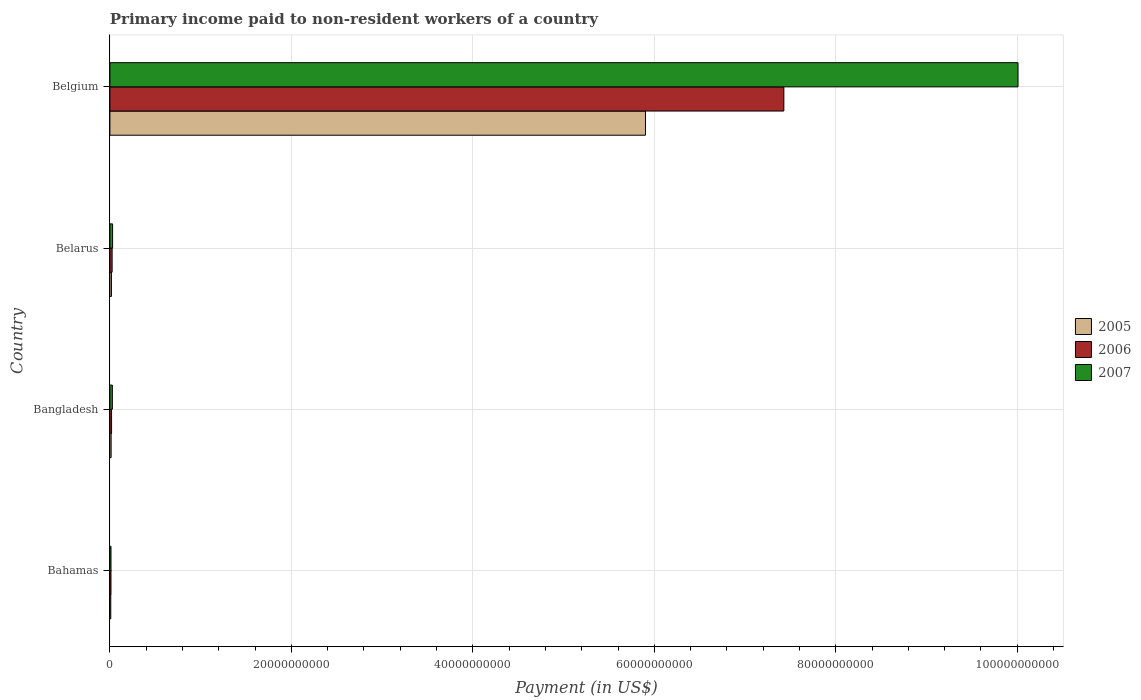How many different coloured bars are there?
Ensure brevity in your answer.  3. How many bars are there on the 2nd tick from the top?
Offer a terse response. 3. What is the amount paid to workers in 2005 in Belarus?
Your response must be concise. 1.68e+08. Across all countries, what is the maximum amount paid to workers in 2005?
Provide a short and direct response. 5.90e+1. Across all countries, what is the minimum amount paid to workers in 2006?
Your response must be concise. 1.19e+08. In which country was the amount paid to workers in 2005 maximum?
Your answer should be compact. Belgium. In which country was the amount paid to workers in 2005 minimum?
Provide a short and direct response. Bahamas. What is the total amount paid to workers in 2006 in the graph?
Keep it short and to the point. 7.48e+1. What is the difference between the amount paid to workers in 2006 in Bangladesh and that in Belarus?
Your answer should be very brief. -6.22e+07. What is the difference between the amount paid to workers in 2005 in Bahamas and the amount paid to workers in 2007 in Belarus?
Give a very brief answer. -2.00e+08. What is the average amount paid to workers in 2006 per country?
Your answer should be compact. 1.87e+1. What is the difference between the amount paid to workers in 2007 and amount paid to workers in 2005 in Bangladesh?
Keep it short and to the point. 1.37e+08. What is the ratio of the amount paid to workers in 2007 in Bahamas to that in Belarus?
Your answer should be compact. 0.41. Is the difference between the amount paid to workers in 2007 in Bangladesh and Belgium greater than the difference between the amount paid to workers in 2005 in Bangladesh and Belgium?
Give a very brief answer. No. What is the difference between the highest and the second highest amount paid to workers in 2007?
Your response must be concise. 9.98e+1. What is the difference between the highest and the lowest amount paid to workers in 2005?
Keep it short and to the point. 5.89e+1. How are the legend labels stacked?
Your response must be concise. Vertical. What is the title of the graph?
Offer a terse response. Primary income paid to non-resident workers of a country. Does "1982" appear as one of the legend labels in the graph?
Offer a very short reply. No. What is the label or title of the X-axis?
Keep it short and to the point. Payment (in US$). What is the label or title of the Y-axis?
Give a very brief answer. Country. What is the Payment (in US$) in 2005 in Bahamas?
Keep it short and to the point. 9.70e+07. What is the Payment (in US$) in 2006 in Bahamas?
Give a very brief answer. 1.19e+08. What is the Payment (in US$) in 2007 in Bahamas?
Your answer should be very brief. 1.21e+08. What is the Payment (in US$) of 2005 in Bangladesh?
Offer a terse response. 1.35e+08. What is the Payment (in US$) of 2006 in Bangladesh?
Offer a very short reply. 1.84e+08. What is the Payment (in US$) in 2007 in Bangladesh?
Provide a short and direct response. 2.72e+08. What is the Payment (in US$) of 2005 in Belarus?
Keep it short and to the point. 1.68e+08. What is the Payment (in US$) of 2006 in Belarus?
Your answer should be compact. 2.47e+08. What is the Payment (in US$) in 2007 in Belarus?
Your answer should be very brief. 2.97e+08. What is the Payment (in US$) of 2005 in Belgium?
Offer a terse response. 5.90e+1. What is the Payment (in US$) in 2006 in Belgium?
Your answer should be compact. 7.43e+1. What is the Payment (in US$) of 2007 in Belgium?
Give a very brief answer. 1.00e+11. Across all countries, what is the maximum Payment (in US$) of 2005?
Make the answer very short. 5.90e+1. Across all countries, what is the maximum Payment (in US$) in 2006?
Keep it short and to the point. 7.43e+1. Across all countries, what is the maximum Payment (in US$) in 2007?
Give a very brief answer. 1.00e+11. Across all countries, what is the minimum Payment (in US$) in 2005?
Offer a terse response. 9.70e+07. Across all countries, what is the minimum Payment (in US$) in 2006?
Offer a very short reply. 1.19e+08. Across all countries, what is the minimum Payment (in US$) of 2007?
Give a very brief answer. 1.21e+08. What is the total Payment (in US$) of 2005 in the graph?
Provide a short and direct response. 5.94e+1. What is the total Payment (in US$) in 2006 in the graph?
Keep it short and to the point. 7.48e+1. What is the total Payment (in US$) of 2007 in the graph?
Offer a very short reply. 1.01e+11. What is the difference between the Payment (in US$) in 2005 in Bahamas and that in Bangladesh?
Provide a short and direct response. -3.82e+07. What is the difference between the Payment (in US$) in 2006 in Bahamas and that in Bangladesh?
Your response must be concise. -6.50e+07. What is the difference between the Payment (in US$) in 2007 in Bahamas and that in Bangladesh?
Your answer should be compact. -1.50e+08. What is the difference between the Payment (in US$) of 2005 in Bahamas and that in Belarus?
Offer a terse response. -7.14e+07. What is the difference between the Payment (in US$) of 2006 in Bahamas and that in Belarus?
Give a very brief answer. -1.27e+08. What is the difference between the Payment (in US$) of 2007 in Bahamas and that in Belarus?
Your answer should be compact. -1.76e+08. What is the difference between the Payment (in US$) in 2005 in Bahamas and that in Belgium?
Provide a succinct answer. -5.89e+1. What is the difference between the Payment (in US$) in 2006 in Bahamas and that in Belgium?
Your response must be concise. -7.42e+1. What is the difference between the Payment (in US$) in 2007 in Bahamas and that in Belgium?
Offer a very short reply. -1.00e+11. What is the difference between the Payment (in US$) in 2005 in Bangladesh and that in Belarus?
Provide a short and direct response. -3.32e+07. What is the difference between the Payment (in US$) in 2006 in Bangladesh and that in Belarus?
Your response must be concise. -6.22e+07. What is the difference between the Payment (in US$) in 2007 in Bangladesh and that in Belarus?
Offer a terse response. -2.54e+07. What is the difference between the Payment (in US$) in 2005 in Bangladesh and that in Belgium?
Provide a succinct answer. -5.89e+1. What is the difference between the Payment (in US$) in 2006 in Bangladesh and that in Belgium?
Your answer should be very brief. -7.41e+1. What is the difference between the Payment (in US$) of 2007 in Bangladesh and that in Belgium?
Give a very brief answer. -9.98e+1. What is the difference between the Payment (in US$) in 2005 in Belarus and that in Belgium?
Make the answer very short. -5.89e+1. What is the difference between the Payment (in US$) of 2006 in Belarus and that in Belgium?
Provide a short and direct response. -7.40e+1. What is the difference between the Payment (in US$) in 2007 in Belarus and that in Belgium?
Make the answer very short. -9.98e+1. What is the difference between the Payment (in US$) in 2005 in Bahamas and the Payment (in US$) in 2006 in Bangladesh?
Your answer should be compact. -8.74e+07. What is the difference between the Payment (in US$) of 2005 in Bahamas and the Payment (in US$) of 2007 in Bangladesh?
Your response must be concise. -1.75e+08. What is the difference between the Payment (in US$) of 2006 in Bahamas and the Payment (in US$) of 2007 in Bangladesh?
Ensure brevity in your answer.  -1.52e+08. What is the difference between the Payment (in US$) of 2005 in Bahamas and the Payment (in US$) of 2006 in Belarus?
Provide a succinct answer. -1.50e+08. What is the difference between the Payment (in US$) in 2005 in Bahamas and the Payment (in US$) in 2007 in Belarus?
Offer a terse response. -2.00e+08. What is the difference between the Payment (in US$) in 2006 in Bahamas and the Payment (in US$) in 2007 in Belarus?
Provide a succinct answer. -1.78e+08. What is the difference between the Payment (in US$) in 2005 in Bahamas and the Payment (in US$) in 2006 in Belgium?
Make the answer very short. -7.42e+1. What is the difference between the Payment (in US$) in 2005 in Bahamas and the Payment (in US$) in 2007 in Belgium?
Your answer should be compact. -1.00e+11. What is the difference between the Payment (in US$) of 2006 in Bahamas and the Payment (in US$) of 2007 in Belgium?
Your answer should be compact. -1.00e+11. What is the difference between the Payment (in US$) in 2005 in Bangladesh and the Payment (in US$) in 2006 in Belarus?
Make the answer very short. -1.11e+08. What is the difference between the Payment (in US$) in 2005 in Bangladesh and the Payment (in US$) in 2007 in Belarus?
Make the answer very short. -1.62e+08. What is the difference between the Payment (in US$) in 2006 in Bangladesh and the Payment (in US$) in 2007 in Belarus?
Ensure brevity in your answer.  -1.13e+08. What is the difference between the Payment (in US$) in 2005 in Bangladesh and the Payment (in US$) in 2006 in Belgium?
Offer a very short reply. -7.41e+1. What is the difference between the Payment (in US$) in 2005 in Bangladesh and the Payment (in US$) in 2007 in Belgium?
Your answer should be very brief. -1.00e+11. What is the difference between the Payment (in US$) in 2006 in Bangladesh and the Payment (in US$) in 2007 in Belgium?
Provide a succinct answer. -9.99e+1. What is the difference between the Payment (in US$) in 2005 in Belarus and the Payment (in US$) in 2006 in Belgium?
Your response must be concise. -7.41e+1. What is the difference between the Payment (in US$) in 2005 in Belarus and the Payment (in US$) in 2007 in Belgium?
Provide a short and direct response. -9.99e+1. What is the difference between the Payment (in US$) of 2006 in Belarus and the Payment (in US$) of 2007 in Belgium?
Your answer should be very brief. -9.98e+1. What is the average Payment (in US$) in 2005 per country?
Offer a terse response. 1.49e+1. What is the average Payment (in US$) of 2006 per country?
Ensure brevity in your answer.  1.87e+1. What is the average Payment (in US$) in 2007 per country?
Your response must be concise. 2.52e+1. What is the difference between the Payment (in US$) in 2005 and Payment (in US$) in 2006 in Bahamas?
Make the answer very short. -2.24e+07. What is the difference between the Payment (in US$) of 2005 and Payment (in US$) of 2007 in Bahamas?
Your response must be concise. -2.43e+07. What is the difference between the Payment (in US$) in 2006 and Payment (in US$) in 2007 in Bahamas?
Offer a terse response. -1.88e+06. What is the difference between the Payment (in US$) in 2005 and Payment (in US$) in 2006 in Bangladesh?
Ensure brevity in your answer.  -4.93e+07. What is the difference between the Payment (in US$) of 2005 and Payment (in US$) of 2007 in Bangladesh?
Provide a short and direct response. -1.37e+08. What is the difference between the Payment (in US$) of 2006 and Payment (in US$) of 2007 in Bangladesh?
Keep it short and to the point. -8.73e+07. What is the difference between the Payment (in US$) of 2005 and Payment (in US$) of 2006 in Belarus?
Give a very brief answer. -7.82e+07. What is the difference between the Payment (in US$) of 2005 and Payment (in US$) of 2007 in Belarus?
Your response must be concise. -1.29e+08. What is the difference between the Payment (in US$) of 2006 and Payment (in US$) of 2007 in Belarus?
Provide a succinct answer. -5.05e+07. What is the difference between the Payment (in US$) of 2005 and Payment (in US$) of 2006 in Belgium?
Ensure brevity in your answer.  -1.52e+1. What is the difference between the Payment (in US$) of 2005 and Payment (in US$) of 2007 in Belgium?
Offer a terse response. -4.11e+1. What is the difference between the Payment (in US$) in 2006 and Payment (in US$) in 2007 in Belgium?
Provide a short and direct response. -2.58e+1. What is the ratio of the Payment (in US$) of 2005 in Bahamas to that in Bangladesh?
Offer a very short reply. 0.72. What is the ratio of the Payment (in US$) of 2006 in Bahamas to that in Bangladesh?
Give a very brief answer. 0.65. What is the ratio of the Payment (in US$) in 2007 in Bahamas to that in Bangladesh?
Your answer should be compact. 0.45. What is the ratio of the Payment (in US$) in 2005 in Bahamas to that in Belarus?
Your response must be concise. 0.58. What is the ratio of the Payment (in US$) in 2006 in Bahamas to that in Belarus?
Give a very brief answer. 0.48. What is the ratio of the Payment (in US$) in 2007 in Bahamas to that in Belarus?
Make the answer very short. 0.41. What is the ratio of the Payment (in US$) of 2005 in Bahamas to that in Belgium?
Offer a very short reply. 0. What is the ratio of the Payment (in US$) in 2006 in Bahamas to that in Belgium?
Ensure brevity in your answer.  0. What is the ratio of the Payment (in US$) of 2007 in Bahamas to that in Belgium?
Keep it short and to the point. 0. What is the ratio of the Payment (in US$) of 2005 in Bangladesh to that in Belarus?
Give a very brief answer. 0.8. What is the ratio of the Payment (in US$) of 2006 in Bangladesh to that in Belarus?
Offer a terse response. 0.75. What is the ratio of the Payment (in US$) of 2007 in Bangladesh to that in Belarus?
Your answer should be very brief. 0.91. What is the ratio of the Payment (in US$) of 2005 in Bangladesh to that in Belgium?
Offer a terse response. 0. What is the ratio of the Payment (in US$) in 2006 in Bangladesh to that in Belgium?
Offer a terse response. 0. What is the ratio of the Payment (in US$) in 2007 in Bangladesh to that in Belgium?
Give a very brief answer. 0. What is the ratio of the Payment (in US$) in 2005 in Belarus to that in Belgium?
Your answer should be compact. 0. What is the ratio of the Payment (in US$) in 2006 in Belarus to that in Belgium?
Ensure brevity in your answer.  0. What is the ratio of the Payment (in US$) in 2007 in Belarus to that in Belgium?
Make the answer very short. 0. What is the difference between the highest and the second highest Payment (in US$) of 2005?
Your response must be concise. 5.89e+1. What is the difference between the highest and the second highest Payment (in US$) in 2006?
Your answer should be very brief. 7.40e+1. What is the difference between the highest and the second highest Payment (in US$) of 2007?
Ensure brevity in your answer.  9.98e+1. What is the difference between the highest and the lowest Payment (in US$) in 2005?
Make the answer very short. 5.89e+1. What is the difference between the highest and the lowest Payment (in US$) of 2006?
Offer a very short reply. 7.42e+1. What is the difference between the highest and the lowest Payment (in US$) of 2007?
Ensure brevity in your answer.  1.00e+11. 